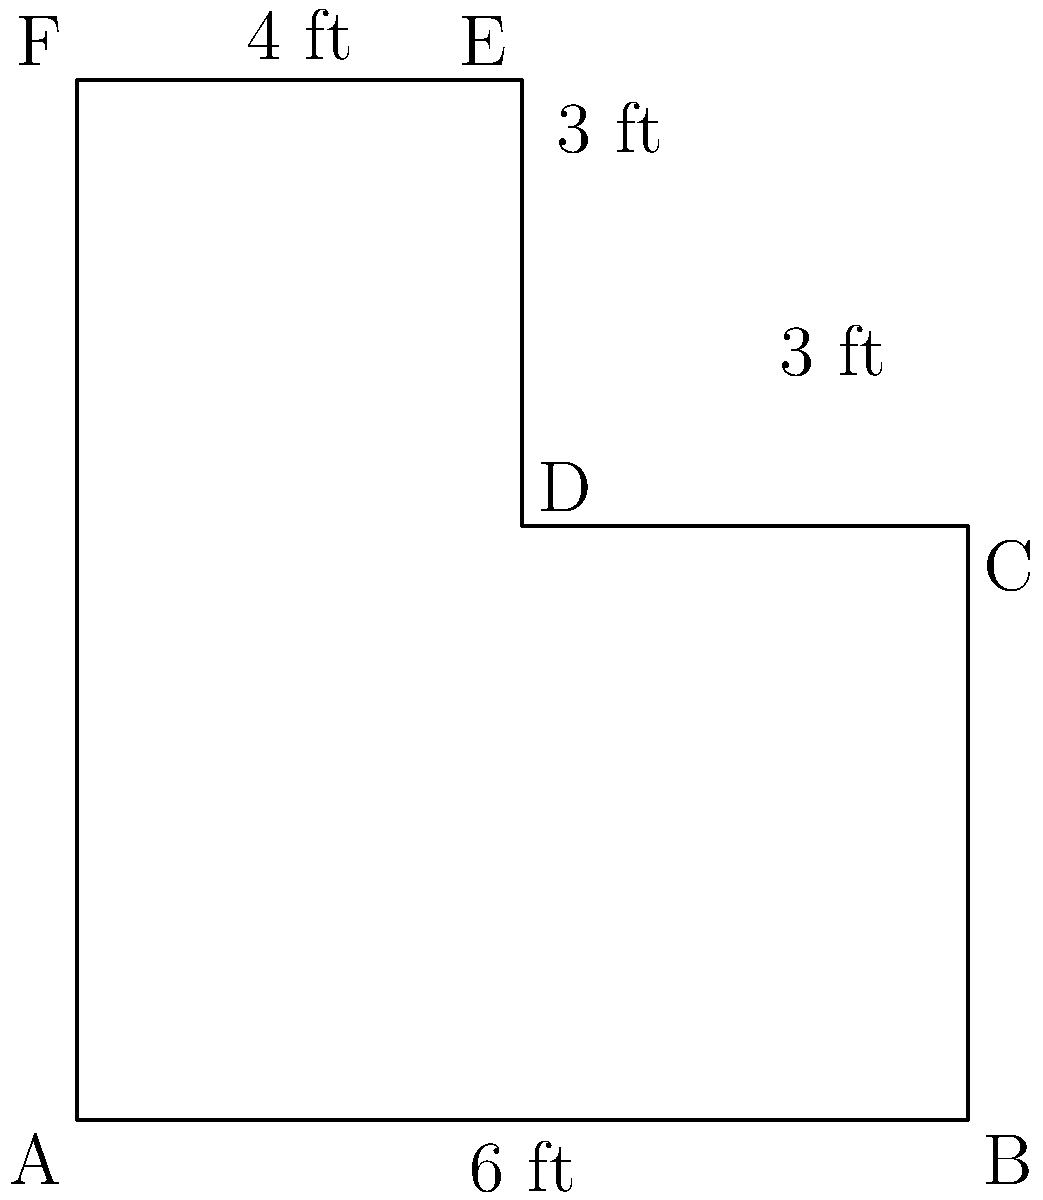You're helping a client install new edging on their L-shaped kitchen counter. The dimensions are shown in the diagram. What is the total perimeter of the counter that needs edging? To find the perimeter, we need to add up all the outer edges of the L-shaped counter:

1. Start with the bottom edge: $6$ ft
2. Right side: $4$ ft
3. Top of the shorter part: $3$ ft
4. Right side of the longer part: $3$ ft
5. Top of the longer part: $4$ ft
6. Left side: $7$ ft

Now, let's add all these lengths:

$$6 + 4 + 3 + 3 + 4 + 7 = 27$$

Therefore, the total perimeter of the counter is $27$ feet.
Answer: $27$ feet 